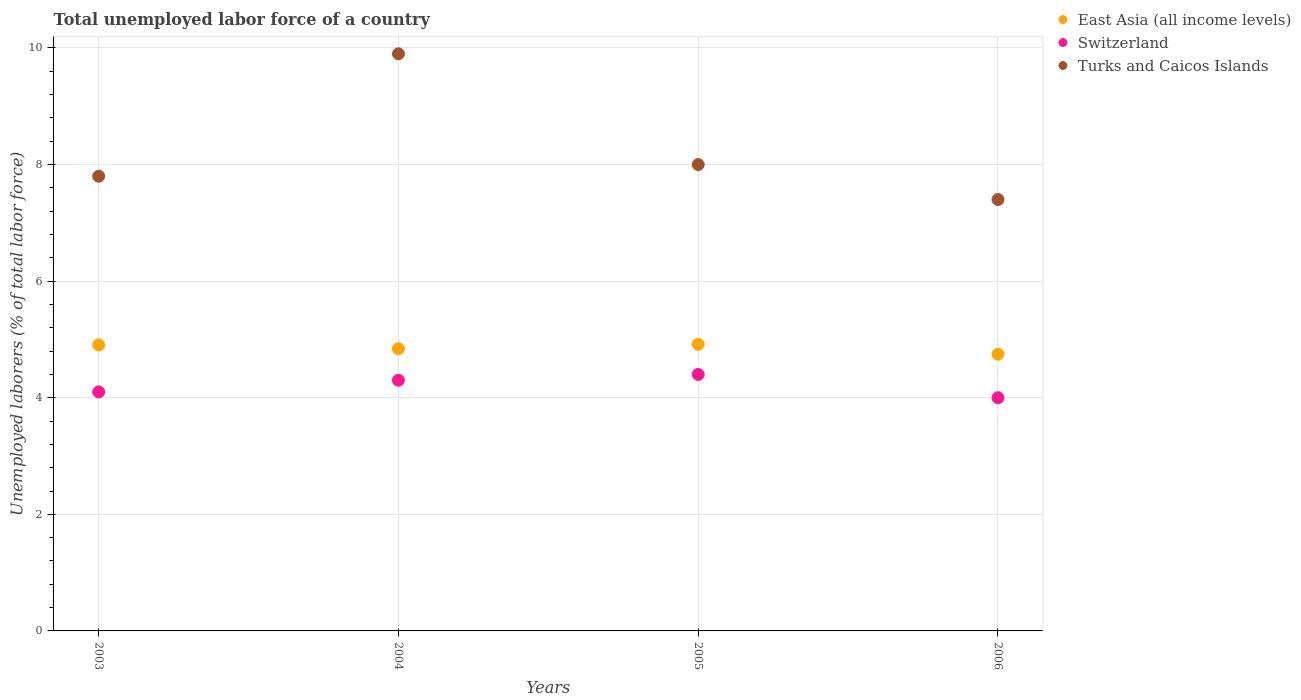What is the total unemployed labor force in East Asia (all income levels) in 2006?
Your response must be concise. 4.75. Across all years, what is the maximum total unemployed labor force in East Asia (all income levels)?
Ensure brevity in your answer.  4.92. In which year was the total unemployed labor force in Switzerland maximum?
Offer a terse response. 2005. What is the total total unemployed labor force in Switzerland in the graph?
Offer a terse response. 16.8. What is the difference between the total unemployed labor force in Switzerland in 2003 and that in 2005?
Your response must be concise. -0.3. What is the difference between the total unemployed labor force in Turks and Caicos Islands in 2006 and the total unemployed labor force in Switzerland in 2003?
Your response must be concise. 3.3. What is the average total unemployed labor force in Turks and Caicos Islands per year?
Give a very brief answer. 8.27. In the year 2004, what is the difference between the total unemployed labor force in Turks and Caicos Islands and total unemployed labor force in East Asia (all income levels)?
Offer a very short reply. 5.06. What is the ratio of the total unemployed labor force in Switzerland in 2003 to that in 2004?
Make the answer very short. 0.95. Is the total unemployed labor force in East Asia (all income levels) in 2003 less than that in 2004?
Your answer should be very brief. No. What is the difference between the highest and the second highest total unemployed labor force in East Asia (all income levels)?
Your response must be concise. 0.01. What is the difference between the highest and the lowest total unemployed labor force in Switzerland?
Make the answer very short. 0.4. In how many years, is the total unemployed labor force in Turks and Caicos Islands greater than the average total unemployed labor force in Turks and Caicos Islands taken over all years?
Provide a succinct answer. 1. Is it the case that in every year, the sum of the total unemployed labor force in East Asia (all income levels) and total unemployed labor force in Switzerland  is greater than the total unemployed labor force in Turks and Caicos Islands?
Your response must be concise. No. Is the total unemployed labor force in Switzerland strictly greater than the total unemployed labor force in East Asia (all income levels) over the years?
Provide a succinct answer. No. How many dotlines are there?
Ensure brevity in your answer.  3. Where does the legend appear in the graph?
Give a very brief answer. Top right. How many legend labels are there?
Your answer should be very brief. 3. How are the legend labels stacked?
Ensure brevity in your answer.  Vertical. What is the title of the graph?
Give a very brief answer. Total unemployed labor force of a country. Does "Spain" appear as one of the legend labels in the graph?
Your answer should be compact. No. What is the label or title of the Y-axis?
Make the answer very short. Unemployed laborers (% of total labor force). What is the Unemployed laborers (% of total labor force) of East Asia (all income levels) in 2003?
Provide a short and direct response. 4.91. What is the Unemployed laborers (% of total labor force) of Switzerland in 2003?
Make the answer very short. 4.1. What is the Unemployed laborers (% of total labor force) of Turks and Caicos Islands in 2003?
Keep it short and to the point. 7.8. What is the Unemployed laborers (% of total labor force) of East Asia (all income levels) in 2004?
Provide a succinct answer. 4.84. What is the Unemployed laborers (% of total labor force) of Switzerland in 2004?
Provide a succinct answer. 4.3. What is the Unemployed laborers (% of total labor force) of Turks and Caicos Islands in 2004?
Give a very brief answer. 9.9. What is the Unemployed laborers (% of total labor force) of East Asia (all income levels) in 2005?
Your answer should be compact. 4.92. What is the Unemployed laborers (% of total labor force) of Switzerland in 2005?
Make the answer very short. 4.4. What is the Unemployed laborers (% of total labor force) in Turks and Caicos Islands in 2005?
Provide a succinct answer. 8. What is the Unemployed laborers (% of total labor force) of East Asia (all income levels) in 2006?
Make the answer very short. 4.75. What is the Unemployed laborers (% of total labor force) in Turks and Caicos Islands in 2006?
Offer a very short reply. 7.4. Across all years, what is the maximum Unemployed laborers (% of total labor force) in East Asia (all income levels)?
Provide a short and direct response. 4.92. Across all years, what is the maximum Unemployed laborers (% of total labor force) in Switzerland?
Give a very brief answer. 4.4. Across all years, what is the maximum Unemployed laborers (% of total labor force) of Turks and Caicos Islands?
Provide a succinct answer. 9.9. Across all years, what is the minimum Unemployed laborers (% of total labor force) of East Asia (all income levels)?
Make the answer very short. 4.75. Across all years, what is the minimum Unemployed laborers (% of total labor force) in Switzerland?
Offer a very short reply. 4. Across all years, what is the minimum Unemployed laborers (% of total labor force) in Turks and Caicos Islands?
Give a very brief answer. 7.4. What is the total Unemployed laborers (% of total labor force) in East Asia (all income levels) in the graph?
Give a very brief answer. 19.41. What is the total Unemployed laborers (% of total labor force) of Turks and Caicos Islands in the graph?
Offer a very short reply. 33.1. What is the difference between the Unemployed laborers (% of total labor force) in East Asia (all income levels) in 2003 and that in 2004?
Keep it short and to the point. 0.06. What is the difference between the Unemployed laborers (% of total labor force) in Switzerland in 2003 and that in 2004?
Provide a succinct answer. -0.2. What is the difference between the Unemployed laborers (% of total labor force) of East Asia (all income levels) in 2003 and that in 2005?
Offer a terse response. -0.01. What is the difference between the Unemployed laborers (% of total labor force) in Switzerland in 2003 and that in 2005?
Your response must be concise. -0.3. What is the difference between the Unemployed laborers (% of total labor force) in Turks and Caicos Islands in 2003 and that in 2005?
Your answer should be compact. -0.2. What is the difference between the Unemployed laborers (% of total labor force) of East Asia (all income levels) in 2003 and that in 2006?
Ensure brevity in your answer.  0.16. What is the difference between the Unemployed laborers (% of total labor force) of East Asia (all income levels) in 2004 and that in 2005?
Offer a terse response. -0.08. What is the difference between the Unemployed laborers (% of total labor force) of Switzerland in 2004 and that in 2005?
Provide a succinct answer. -0.1. What is the difference between the Unemployed laborers (% of total labor force) of Turks and Caicos Islands in 2004 and that in 2005?
Provide a succinct answer. 1.9. What is the difference between the Unemployed laborers (% of total labor force) in East Asia (all income levels) in 2004 and that in 2006?
Your answer should be compact. 0.1. What is the difference between the Unemployed laborers (% of total labor force) of Switzerland in 2004 and that in 2006?
Your response must be concise. 0.3. What is the difference between the Unemployed laborers (% of total labor force) in Turks and Caicos Islands in 2004 and that in 2006?
Make the answer very short. 2.5. What is the difference between the Unemployed laborers (% of total labor force) in East Asia (all income levels) in 2005 and that in 2006?
Offer a very short reply. 0.17. What is the difference between the Unemployed laborers (% of total labor force) of East Asia (all income levels) in 2003 and the Unemployed laborers (% of total labor force) of Switzerland in 2004?
Provide a short and direct response. 0.61. What is the difference between the Unemployed laborers (% of total labor force) in East Asia (all income levels) in 2003 and the Unemployed laborers (% of total labor force) in Turks and Caicos Islands in 2004?
Provide a short and direct response. -4.99. What is the difference between the Unemployed laborers (% of total labor force) in East Asia (all income levels) in 2003 and the Unemployed laborers (% of total labor force) in Switzerland in 2005?
Provide a succinct answer. 0.51. What is the difference between the Unemployed laborers (% of total labor force) in East Asia (all income levels) in 2003 and the Unemployed laborers (% of total labor force) in Turks and Caicos Islands in 2005?
Provide a short and direct response. -3.09. What is the difference between the Unemployed laborers (% of total labor force) of East Asia (all income levels) in 2003 and the Unemployed laborers (% of total labor force) of Switzerland in 2006?
Offer a terse response. 0.91. What is the difference between the Unemployed laborers (% of total labor force) in East Asia (all income levels) in 2003 and the Unemployed laborers (% of total labor force) in Turks and Caicos Islands in 2006?
Provide a short and direct response. -2.49. What is the difference between the Unemployed laborers (% of total labor force) of Switzerland in 2003 and the Unemployed laborers (% of total labor force) of Turks and Caicos Islands in 2006?
Your answer should be very brief. -3.3. What is the difference between the Unemployed laborers (% of total labor force) of East Asia (all income levels) in 2004 and the Unemployed laborers (% of total labor force) of Switzerland in 2005?
Your answer should be compact. 0.44. What is the difference between the Unemployed laborers (% of total labor force) of East Asia (all income levels) in 2004 and the Unemployed laborers (% of total labor force) of Turks and Caicos Islands in 2005?
Ensure brevity in your answer.  -3.16. What is the difference between the Unemployed laborers (% of total labor force) of East Asia (all income levels) in 2004 and the Unemployed laborers (% of total labor force) of Switzerland in 2006?
Your answer should be compact. 0.84. What is the difference between the Unemployed laborers (% of total labor force) of East Asia (all income levels) in 2004 and the Unemployed laborers (% of total labor force) of Turks and Caicos Islands in 2006?
Your response must be concise. -2.56. What is the difference between the Unemployed laborers (% of total labor force) in East Asia (all income levels) in 2005 and the Unemployed laborers (% of total labor force) in Turks and Caicos Islands in 2006?
Your response must be concise. -2.48. What is the average Unemployed laborers (% of total labor force) of East Asia (all income levels) per year?
Provide a short and direct response. 4.85. What is the average Unemployed laborers (% of total labor force) in Switzerland per year?
Offer a very short reply. 4.2. What is the average Unemployed laborers (% of total labor force) in Turks and Caicos Islands per year?
Your answer should be compact. 8.28. In the year 2003, what is the difference between the Unemployed laborers (% of total labor force) in East Asia (all income levels) and Unemployed laborers (% of total labor force) in Switzerland?
Offer a very short reply. 0.81. In the year 2003, what is the difference between the Unemployed laborers (% of total labor force) in East Asia (all income levels) and Unemployed laborers (% of total labor force) in Turks and Caicos Islands?
Provide a succinct answer. -2.89. In the year 2003, what is the difference between the Unemployed laborers (% of total labor force) of Switzerland and Unemployed laborers (% of total labor force) of Turks and Caicos Islands?
Offer a very short reply. -3.7. In the year 2004, what is the difference between the Unemployed laborers (% of total labor force) in East Asia (all income levels) and Unemployed laborers (% of total labor force) in Switzerland?
Ensure brevity in your answer.  0.54. In the year 2004, what is the difference between the Unemployed laborers (% of total labor force) of East Asia (all income levels) and Unemployed laborers (% of total labor force) of Turks and Caicos Islands?
Offer a terse response. -5.06. In the year 2004, what is the difference between the Unemployed laborers (% of total labor force) of Switzerland and Unemployed laborers (% of total labor force) of Turks and Caicos Islands?
Offer a very short reply. -5.6. In the year 2005, what is the difference between the Unemployed laborers (% of total labor force) in East Asia (all income levels) and Unemployed laborers (% of total labor force) in Switzerland?
Provide a short and direct response. 0.52. In the year 2005, what is the difference between the Unemployed laborers (% of total labor force) in East Asia (all income levels) and Unemployed laborers (% of total labor force) in Turks and Caicos Islands?
Offer a terse response. -3.08. In the year 2005, what is the difference between the Unemployed laborers (% of total labor force) in Switzerland and Unemployed laborers (% of total labor force) in Turks and Caicos Islands?
Make the answer very short. -3.6. In the year 2006, what is the difference between the Unemployed laborers (% of total labor force) in East Asia (all income levels) and Unemployed laborers (% of total labor force) in Switzerland?
Offer a terse response. 0.75. In the year 2006, what is the difference between the Unemployed laborers (% of total labor force) of East Asia (all income levels) and Unemployed laborers (% of total labor force) of Turks and Caicos Islands?
Your answer should be very brief. -2.65. In the year 2006, what is the difference between the Unemployed laborers (% of total labor force) of Switzerland and Unemployed laborers (% of total labor force) of Turks and Caicos Islands?
Offer a terse response. -3.4. What is the ratio of the Unemployed laborers (% of total labor force) of East Asia (all income levels) in 2003 to that in 2004?
Your answer should be compact. 1.01. What is the ratio of the Unemployed laborers (% of total labor force) in Switzerland in 2003 to that in 2004?
Provide a succinct answer. 0.95. What is the ratio of the Unemployed laborers (% of total labor force) of Turks and Caicos Islands in 2003 to that in 2004?
Offer a very short reply. 0.79. What is the ratio of the Unemployed laborers (% of total labor force) in East Asia (all income levels) in 2003 to that in 2005?
Your answer should be very brief. 1. What is the ratio of the Unemployed laborers (% of total labor force) in Switzerland in 2003 to that in 2005?
Provide a short and direct response. 0.93. What is the ratio of the Unemployed laborers (% of total labor force) in Turks and Caicos Islands in 2003 to that in 2005?
Keep it short and to the point. 0.97. What is the ratio of the Unemployed laborers (% of total labor force) of East Asia (all income levels) in 2003 to that in 2006?
Your response must be concise. 1.03. What is the ratio of the Unemployed laborers (% of total labor force) of Switzerland in 2003 to that in 2006?
Keep it short and to the point. 1.02. What is the ratio of the Unemployed laborers (% of total labor force) of Turks and Caicos Islands in 2003 to that in 2006?
Offer a very short reply. 1.05. What is the ratio of the Unemployed laborers (% of total labor force) in East Asia (all income levels) in 2004 to that in 2005?
Provide a succinct answer. 0.98. What is the ratio of the Unemployed laborers (% of total labor force) in Switzerland in 2004 to that in 2005?
Offer a very short reply. 0.98. What is the ratio of the Unemployed laborers (% of total labor force) in Turks and Caicos Islands in 2004 to that in 2005?
Ensure brevity in your answer.  1.24. What is the ratio of the Unemployed laborers (% of total labor force) in East Asia (all income levels) in 2004 to that in 2006?
Provide a succinct answer. 1.02. What is the ratio of the Unemployed laborers (% of total labor force) of Switzerland in 2004 to that in 2006?
Give a very brief answer. 1.07. What is the ratio of the Unemployed laborers (% of total labor force) of Turks and Caicos Islands in 2004 to that in 2006?
Give a very brief answer. 1.34. What is the ratio of the Unemployed laborers (% of total labor force) in East Asia (all income levels) in 2005 to that in 2006?
Offer a very short reply. 1.04. What is the ratio of the Unemployed laborers (% of total labor force) in Turks and Caicos Islands in 2005 to that in 2006?
Make the answer very short. 1.08. What is the difference between the highest and the second highest Unemployed laborers (% of total labor force) of East Asia (all income levels)?
Your response must be concise. 0.01. What is the difference between the highest and the second highest Unemployed laborers (% of total labor force) of Switzerland?
Offer a terse response. 0.1. What is the difference between the highest and the second highest Unemployed laborers (% of total labor force) of Turks and Caicos Islands?
Your response must be concise. 1.9. What is the difference between the highest and the lowest Unemployed laborers (% of total labor force) of East Asia (all income levels)?
Make the answer very short. 0.17. What is the difference between the highest and the lowest Unemployed laborers (% of total labor force) of Turks and Caicos Islands?
Ensure brevity in your answer.  2.5. 